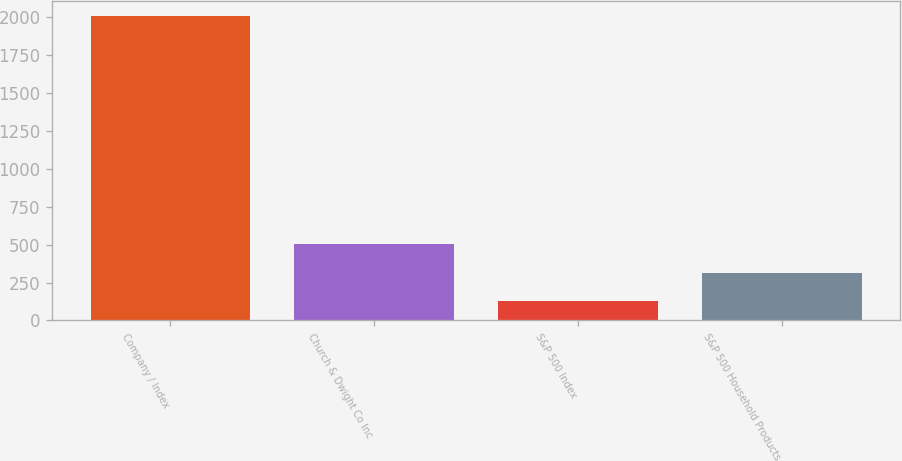Convert chart. <chart><loc_0><loc_0><loc_500><loc_500><bar_chart><fcel>Company / Index<fcel>Church & Dwight Co Inc<fcel>S&P 500 Index<fcel>S&P 500 Household Products<nl><fcel>2007<fcel>503.92<fcel>128.16<fcel>316.04<nl></chart> 